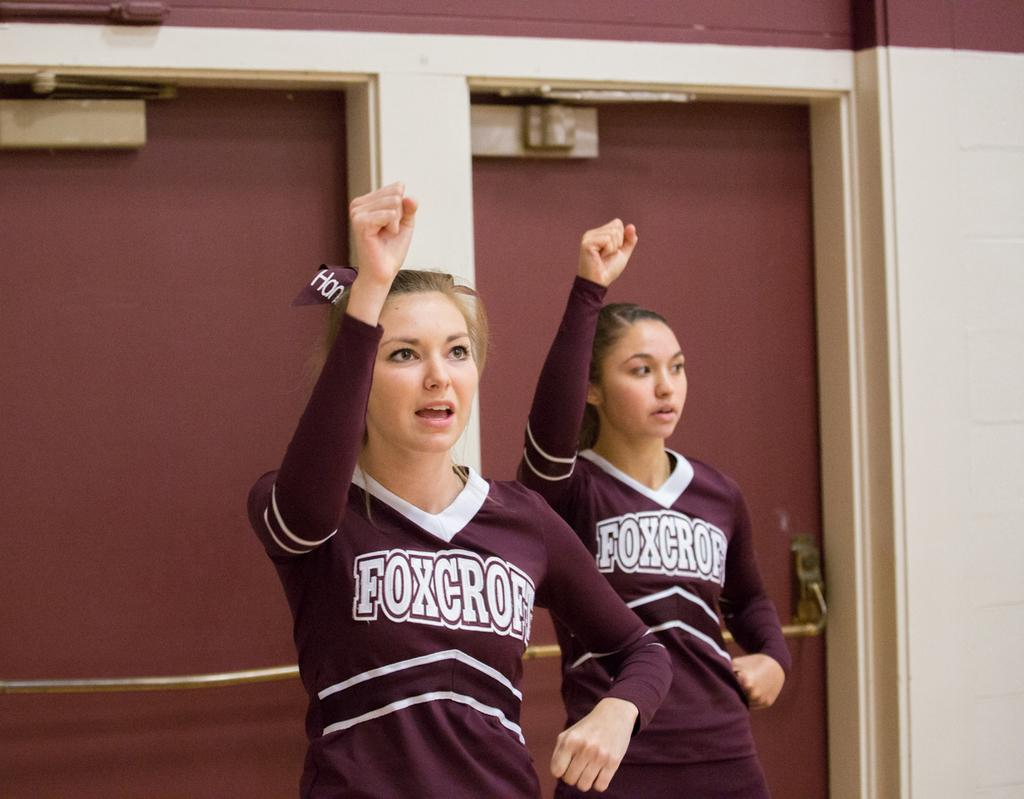<image>
Provide a brief description of the given image. The cheerleaders here are for the team Foxcroft 